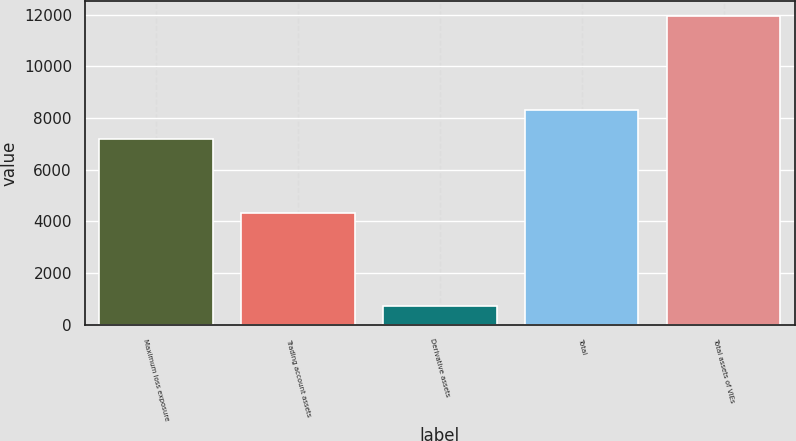<chart> <loc_0><loc_0><loc_500><loc_500><bar_chart><fcel>Maximum loss exposure<fcel>Trading account assets<fcel>Derivative assets<fcel>Total<fcel>Total assets of VIEs<nl><fcel>7184<fcel>4334<fcel>723<fcel>8305.4<fcel>11937<nl></chart> 